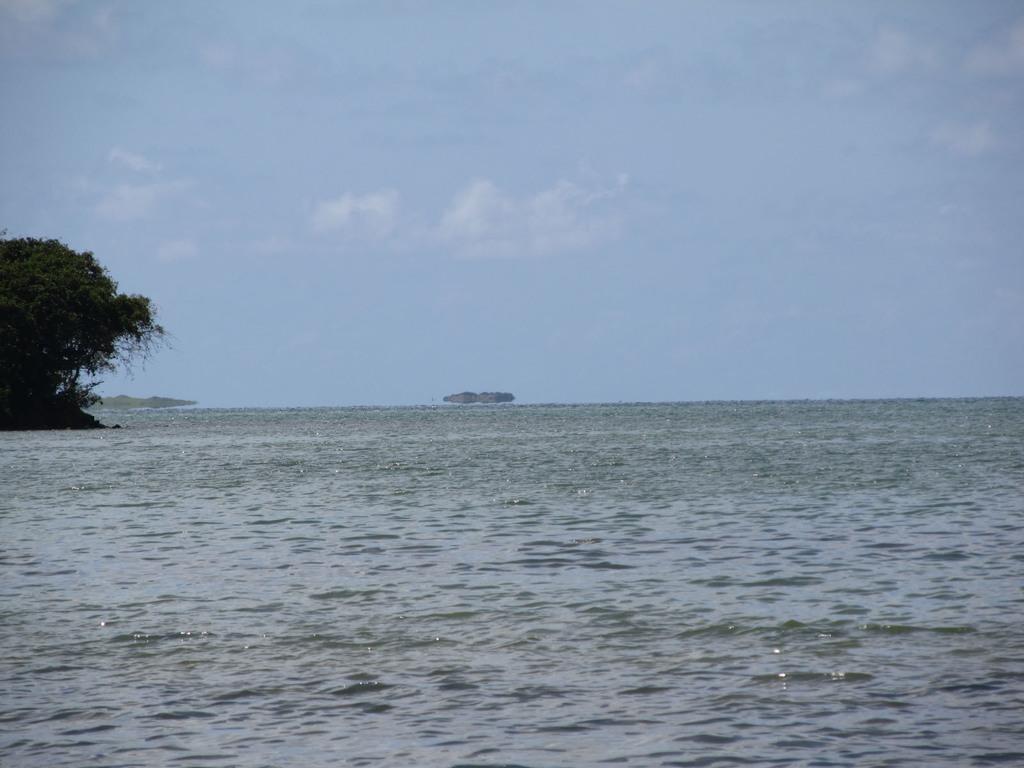Can you describe this image briefly? In this image I can see the sea. In the background I can see few trees in green color and the sky is in blue and white color. 